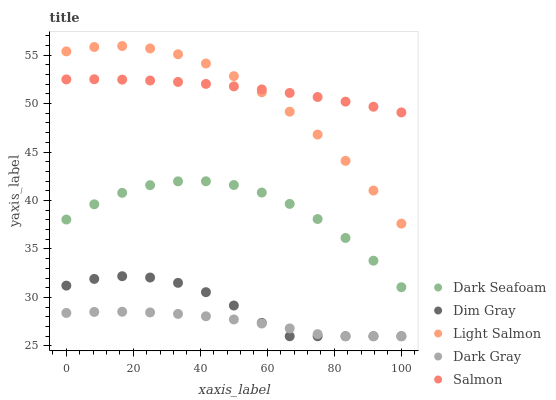Does Dark Gray have the minimum area under the curve?
Answer yes or no. Yes. Does Salmon have the maximum area under the curve?
Answer yes or no. Yes. Does Dark Seafoam have the minimum area under the curve?
Answer yes or no. No. Does Dark Seafoam have the maximum area under the curve?
Answer yes or no. No. Is Salmon the smoothest?
Answer yes or no. Yes. Is Dark Seafoam the roughest?
Answer yes or no. Yes. Is Dim Gray the smoothest?
Answer yes or no. No. Is Dim Gray the roughest?
Answer yes or no. No. Does Dark Gray have the lowest value?
Answer yes or no. Yes. Does Dark Seafoam have the lowest value?
Answer yes or no. No. Does Light Salmon have the highest value?
Answer yes or no. Yes. Does Dark Seafoam have the highest value?
Answer yes or no. No. Is Dim Gray less than Light Salmon?
Answer yes or no. Yes. Is Light Salmon greater than Dark Gray?
Answer yes or no. Yes. Does Salmon intersect Light Salmon?
Answer yes or no. Yes. Is Salmon less than Light Salmon?
Answer yes or no. No. Is Salmon greater than Light Salmon?
Answer yes or no. No. Does Dim Gray intersect Light Salmon?
Answer yes or no. No. 